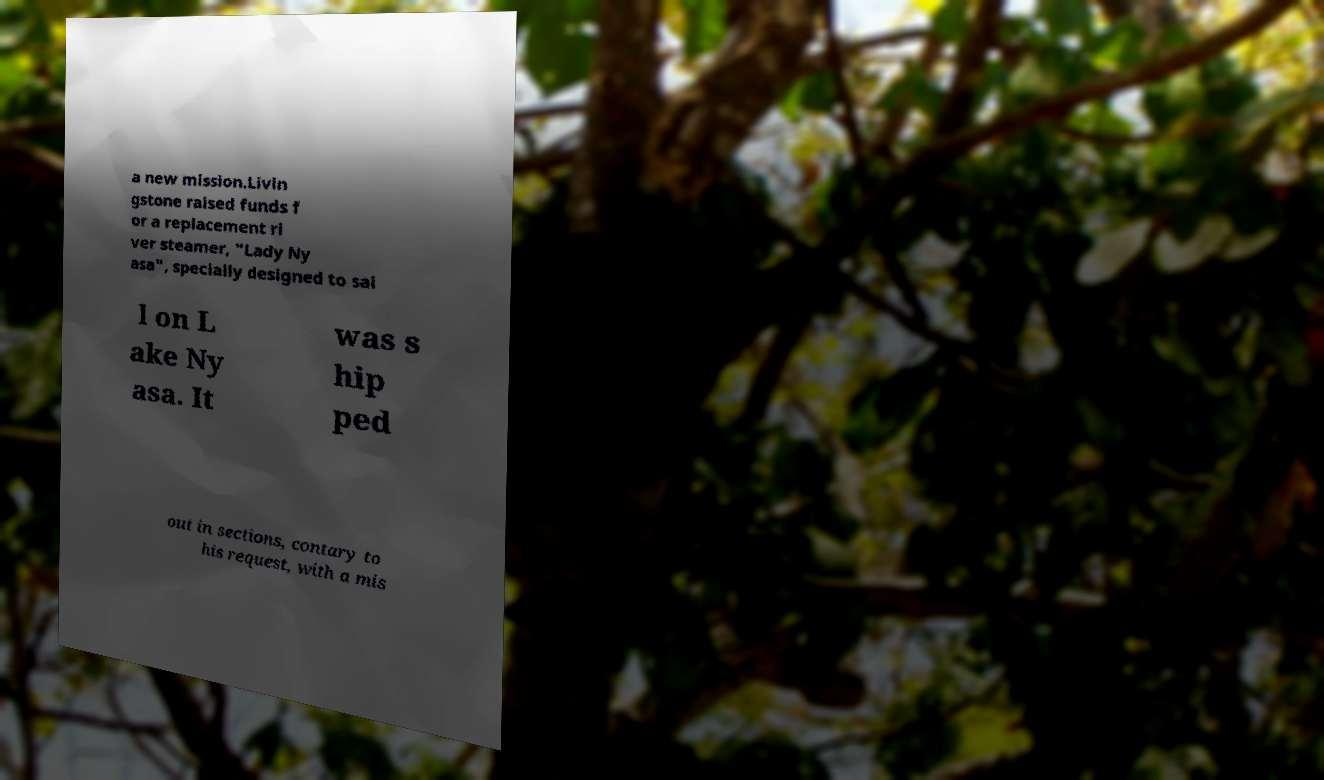Can you accurately transcribe the text from the provided image for me? a new mission.Livin gstone raised funds f or a replacement ri ver steamer, "Lady Ny asa", specially designed to sai l on L ake Ny asa. It was s hip ped out in sections, contary to his request, with a mis 